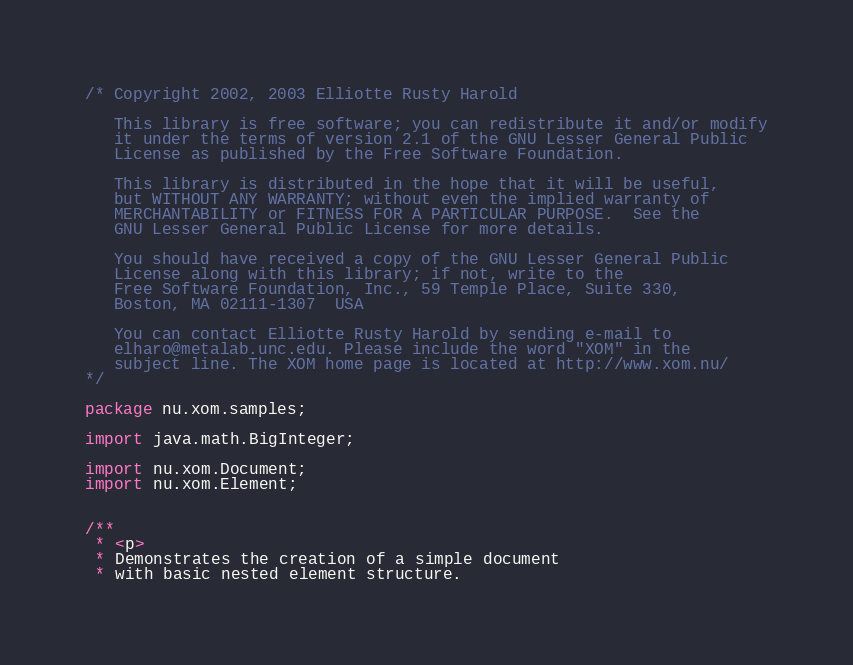<code> <loc_0><loc_0><loc_500><loc_500><_Java_>/* Copyright 2002, 2003 Elliotte Rusty Harold
   
   This library is free software; you can redistribute it and/or modify
   it under the terms of version 2.1 of the GNU Lesser General Public 
   License as published by the Free Software Foundation.
   
   This library is distributed in the hope that it will be useful,
   but WITHOUT ANY WARRANTY; without even the implied warranty of
   MERCHANTABILITY or FITNESS FOR A PARTICULAR PURPOSE.  See the 
   GNU Lesser General Public License for more details.
   
   You should have received a copy of the GNU Lesser General Public
   License along with this library; if not, write to the 
   Free Software Foundation, Inc., 59 Temple Place, Suite 330, 
   Boston, MA 02111-1307  USA
   
   You can contact Elliotte Rusty Harold by sending e-mail to
   elharo@metalab.unc.edu. Please include the word "XOM" in the
   subject line. The XOM home page is located at http://www.xom.nu/
*/

package nu.xom.samples;

import java.math.BigInteger;

import nu.xom.Document;
import nu.xom.Element;


/**
 * <p>
 * Demonstrates the creation of a simple document
 * with basic nested element structure.</code> 